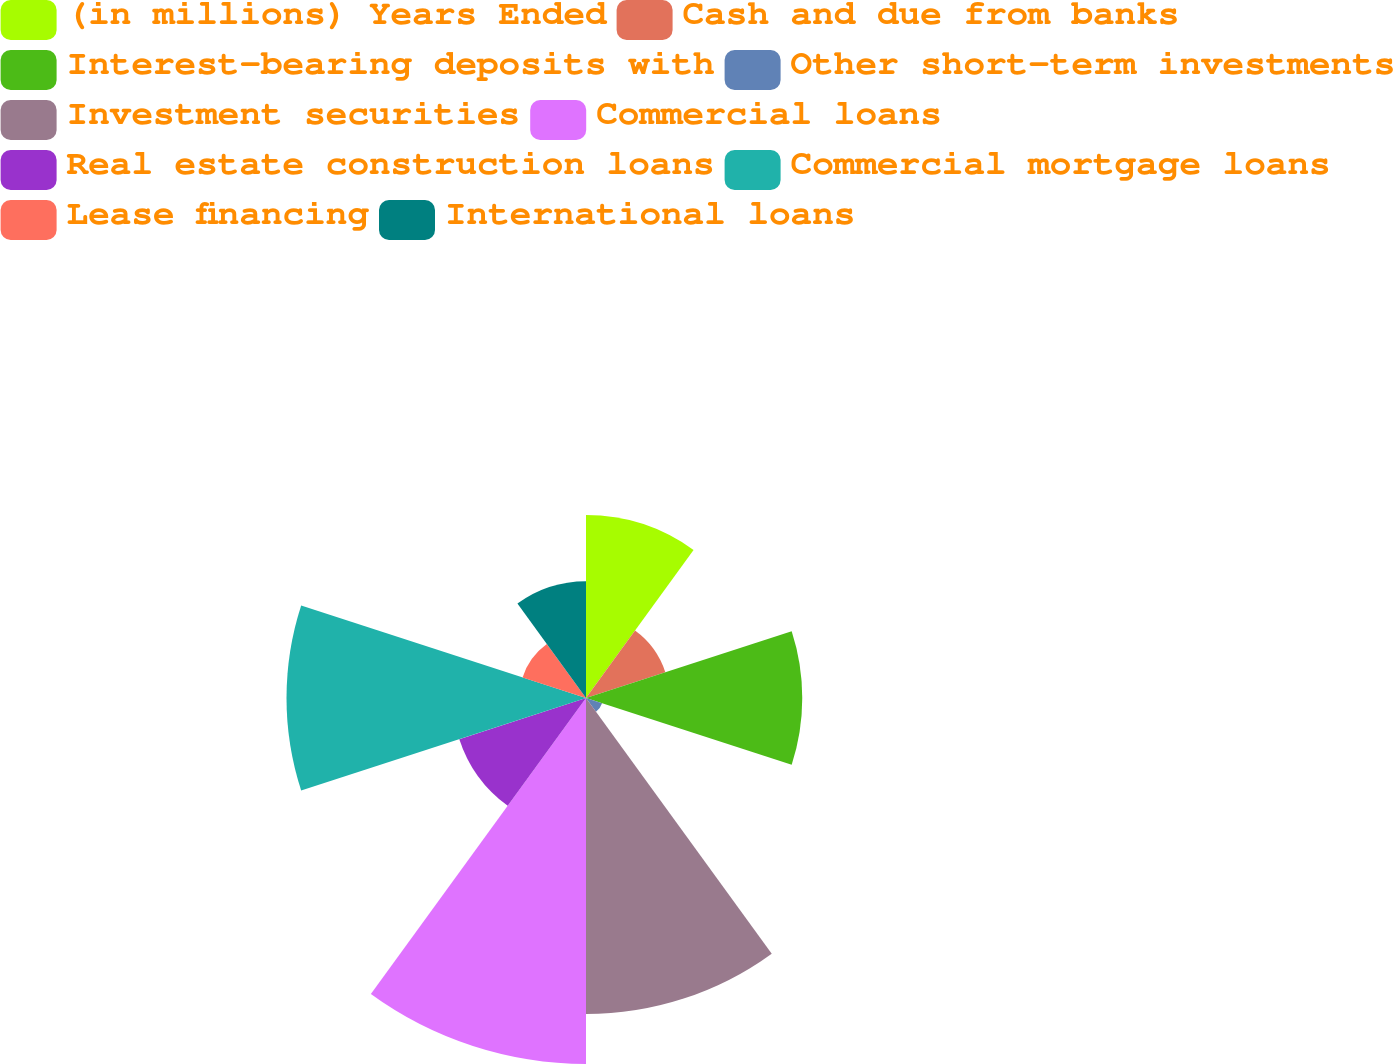Convert chart. <chart><loc_0><loc_0><loc_500><loc_500><pie_chart><fcel>(in millions) Years Ended<fcel>Cash and due from banks<fcel>Interest-bearing deposits with<fcel>Other short-term investments<fcel>Investment securities<fcel>Commercial loans<fcel>Real estate construction loans<fcel>Commercial mortgage loans<fcel>Lease financing<fcel>International loans<nl><fcel>10.18%<fcel>4.64%<fcel>12.03%<fcel>0.94%<fcel>17.58%<fcel>20.36%<fcel>7.41%<fcel>16.66%<fcel>3.71%<fcel>6.49%<nl></chart> 